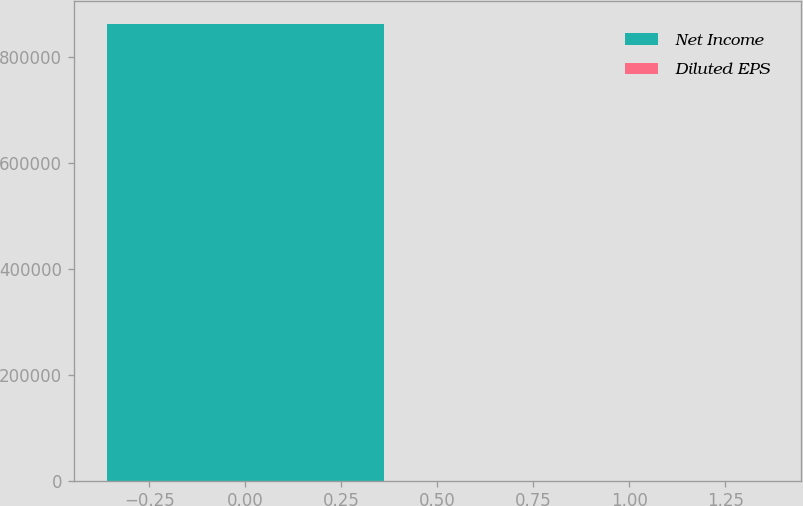Convert chart to OTSL. <chart><loc_0><loc_0><loc_500><loc_500><bar_chart><fcel>Net Income<fcel>Diluted EPS<nl><fcel>861664<fcel>2.76<nl></chart> 